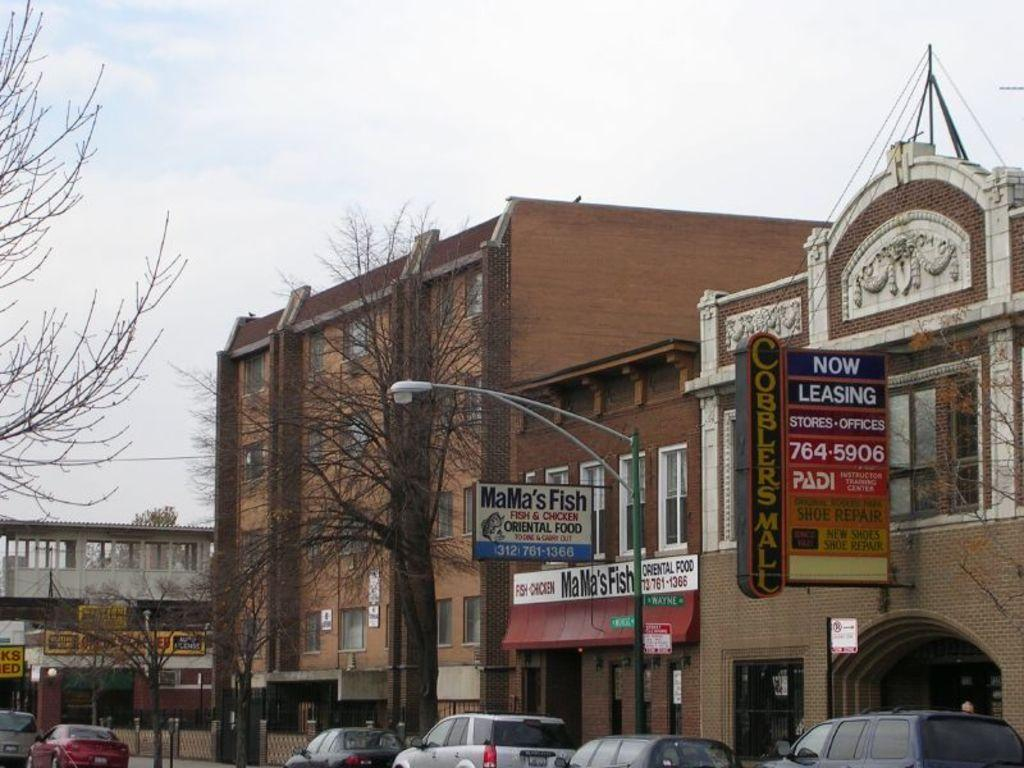What can be seen in the sky in the image? The sky with clouds is visible in the image. What type of structures are present in the image? There are buildings in the image. What are the name boards used for in the image? Name boards are present in the image to indicate names or labels. How old is the street in the image? The street is old in the image. What provides illumination at night in the image? Street lights are visible in the image. What type of security measures are present in the image? Grills are present in the image for security purposes. What type of transportation can be seen on the road in the image? Motor vehicles are on the road in the image. What is your opinion on the direction of the north in the image? The image does not provide any information about the direction of the north, so it is not possible to give an opinion on it. 